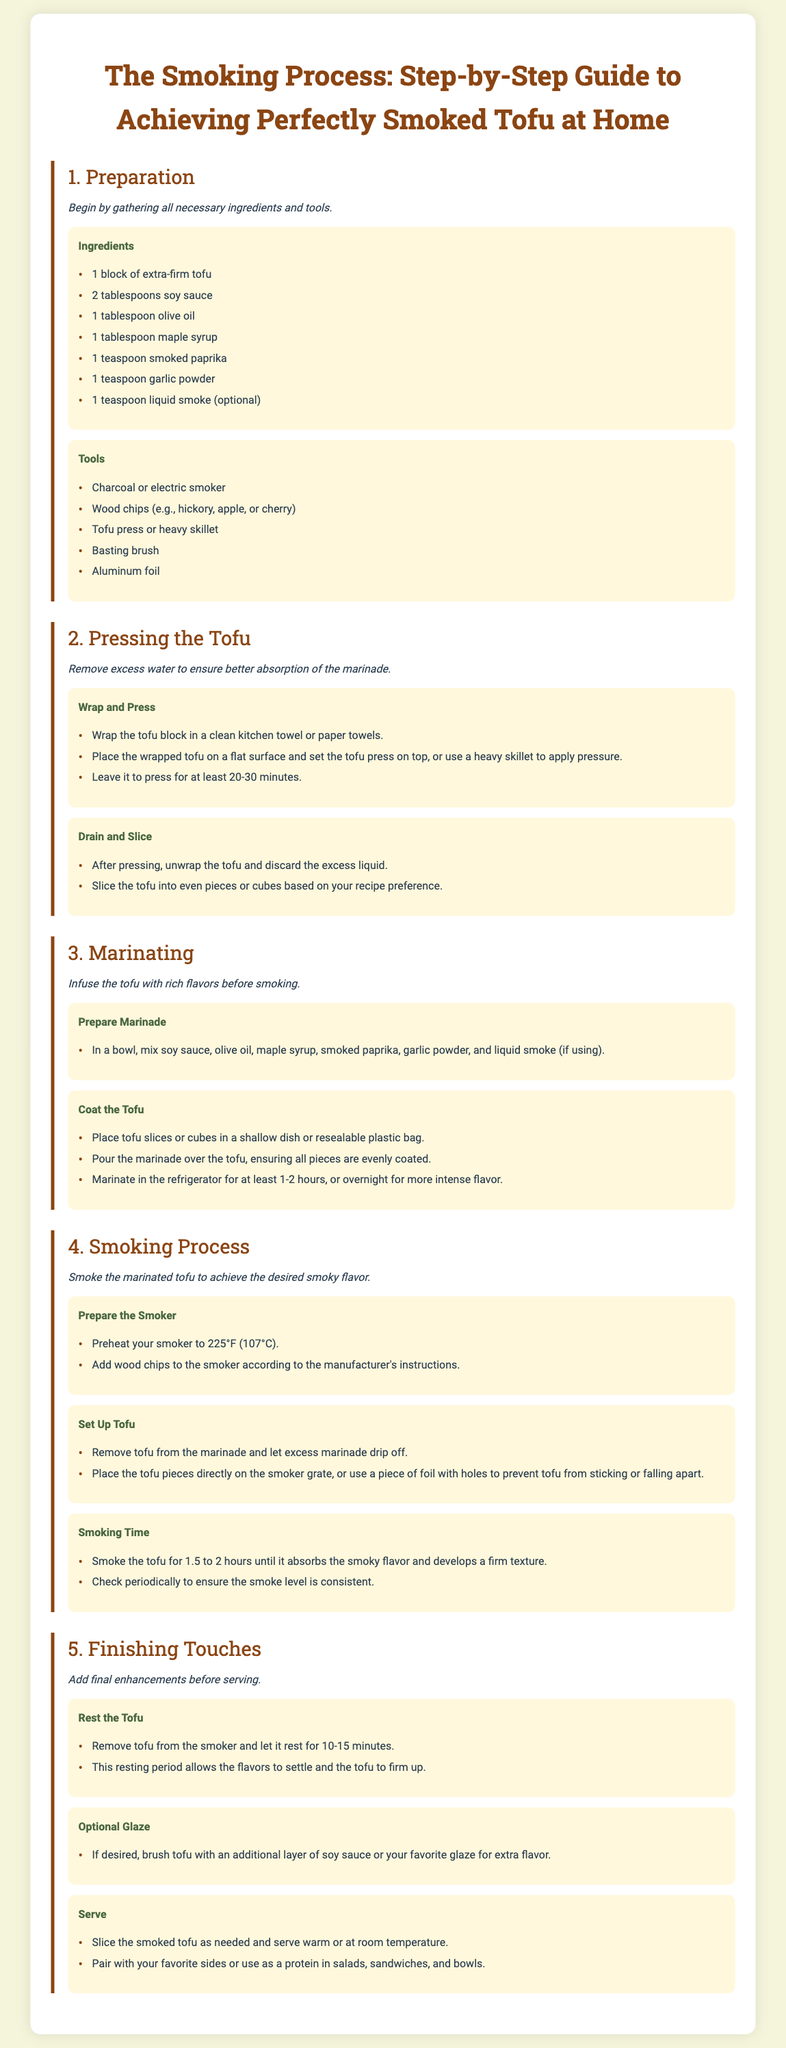What is the first step in the smoking process? The first step is about gathering necessary ingredients and tools for making smoked tofu.
Answer: Preparation How many ingredients are listed for marinating the tofu? The document lists six ingredients in the marinating section.
Answer: Six What temperature should the smoker be preheated to? This information is mentioned in the Smoking Process step.
Answer: 225°F (107°C) What type of tofu is recommended for smoking? The document specifies the type of tofu needed for the recipe.
Answer: Extra-firm tofu How long should the tofu rest after smoking? The resting period for the tofu is given in the Finishing Touches section.
Answer: 10-15 minutes Why is it important to press the tofu? The pressing of the tofu is discussed in terms of its effect on flavor absorption.
Answer: Better absorption of the marinade What should you do during the smoking time? The smoking time includes checking the smoke level periodically.
Answer: Check smoke level How can you enhance the tofu’s flavor before serving? The document suggests an optional final step for flavor enhancement on the finished tofu.
Answer: Brush with additional glaze What should you do with the smoked tofu after resting? The action advised after resting the tofu relates to its preparation for serving.
Answer: Slice and serve 